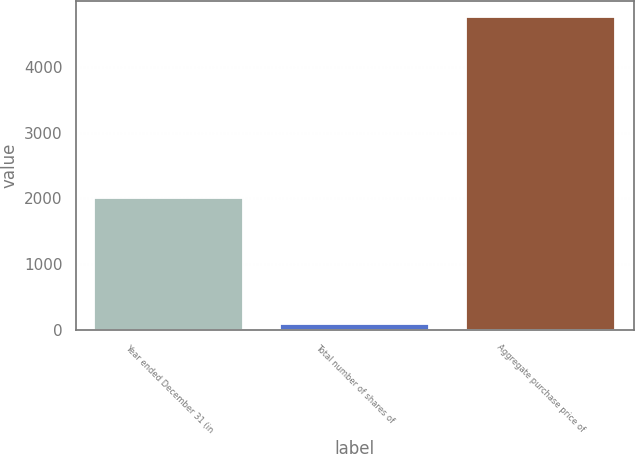Convert chart. <chart><loc_0><loc_0><loc_500><loc_500><bar_chart><fcel>Year ended December 31 (in<fcel>Total number of shares of<fcel>Aggregate purchase price of<nl><fcel>2014<fcel>82.3<fcel>4760<nl></chart> 